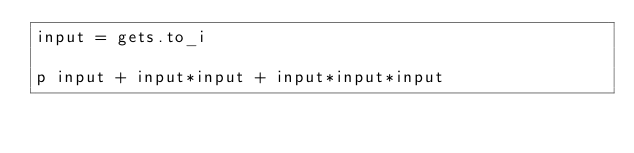Convert code to text. <code><loc_0><loc_0><loc_500><loc_500><_Ruby_>input = gets.to_i

p input + input*input + input*input*input</code> 